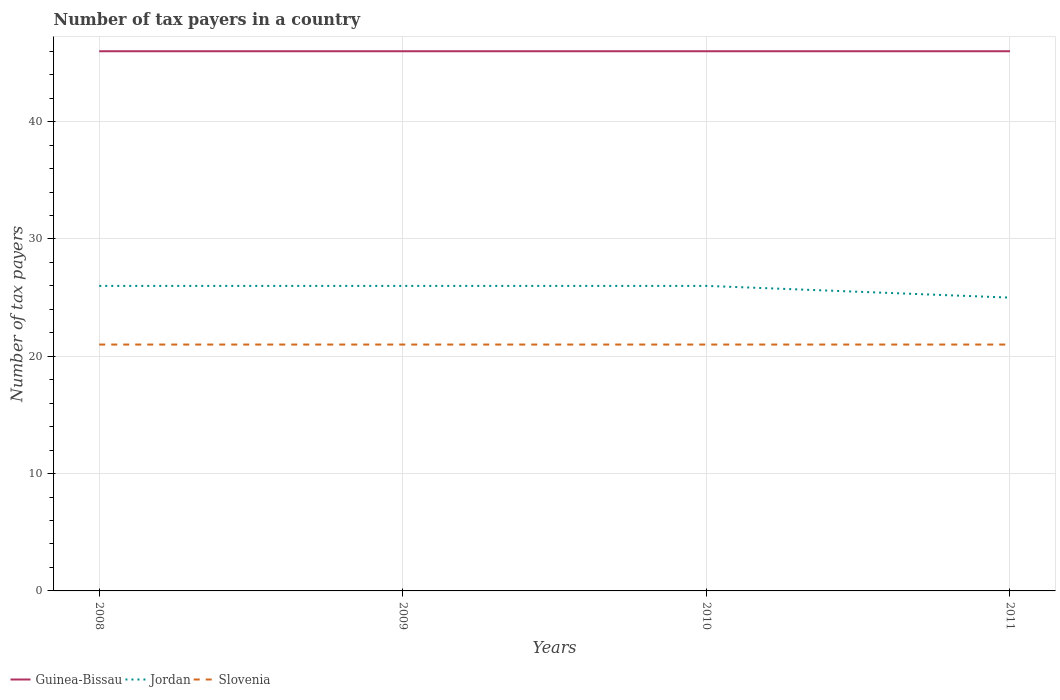How many different coloured lines are there?
Your answer should be compact. 3. Across all years, what is the maximum number of tax payers in in Slovenia?
Ensure brevity in your answer.  21. In which year was the number of tax payers in in Slovenia maximum?
Give a very brief answer. 2008. What is the difference between the highest and the second highest number of tax payers in in Jordan?
Offer a very short reply. 1. What is the difference between the highest and the lowest number of tax payers in in Slovenia?
Provide a succinct answer. 0. How many years are there in the graph?
Provide a short and direct response. 4. What is the difference between two consecutive major ticks on the Y-axis?
Your response must be concise. 10. Are the values on the major ticks of Y-axis written in scientific E-notation?
Ensure brevity in your answer.  No. Does the graph contain any zero values?
Provide a succinct answer. No. How are the legend labels stacked?
Your answer should be compact. Horizontal. What is the title of the graph?
Your answer should be compact. Number of tax payers in a country. Does "South Sudan" appear as one of the legend labels in the graph?
Your answer should be very brief. No. What is the label or title of the Y-axis?
Keep it short and to the point. Number of tax payers. What is the Number of tax payers in Jordan in 2008?
Offer a terse response. 26. What is the Number of tax payers in Slovenia in 2008?
Your answer should be very brief. 21. What is the Number of tax payers of Guinea-Bissau in 2009?
Offer a very short reply. 46. What is the Number of tax payers in Slovenia in 2009?
Your response must be concise. 21. What is the Number of tax payers in Guinea-Bissau in 2010?
Your answer should be compact. 46. What is the Number of tax payers of Slovenia in 2010?
Provide a succinct answer. 21. What is the Number of tax payers in Slovenia in 2011?
Your answer should be compact. 21. Across all years, what is the maximum Number of tax payers in Jordan?
Offer a very short reply. 26. Across all years, what is the maximum Number of tax payers of Slovenia?
Make the answer very short. 21. What is the total Number of tax payers of Guinea-Bissau in the graph?
Your answer should be very brief. 184. What is the total Number of tax payers in Jordan in the graph?
Provide a succinct answer. 103. What is the difference between the Number of tax payers in Guinea-Bissau in 2008 and that in 2009?
Make the answer very short. 0. What is the difference between the Number of tax payers in Jordan in 2008 and that in 2009?
Make the answer very short. 0. What is the difference between the Number of tax payers in Slovenia in 2008 and that in 2009?
Your answer should be very brief. 0. What is the difference between the Number of tax payers in Guinea-Bissau in 2008 and that in 2010?
Provide a short and direct response. 0. What is the difference between the Number of tax payers of Slovenia in 2008 and that in 2010?
Provide a succinct answer. 0. What is the difference between the Number of tax payers in Slovenia in 2008 and that in 2011?
Keep it short and to the point. 0. What is the difference between the Number of tax payers of Jordan in 2009 and that in 2011?
Your answer should be compact. 1. What is the difference between the Number of tax payers in Guinea-Bissau in 2010 and that in 2011?
Keep it short and to the point. 0. What is the difference between the Number of tax payers of Guinea-Bissau in 2008 and the Number of tax payers of Jordan in 2009?
Offer a very short reply. 20. What is the difference between the Number of tax payers in Guinea-Bissau in 2008 and the Number of tax payers in Slovenia in 2009?
Provide a succinct answer. 25. What is the difference between the Number of tax payers of Jordan in 2008 and the Number of tax payers of Slovenia in 2009?
Your answer should be very brief. 5. What is the difference between the Number of tax payers in Guinea-Bissau in 2008 and the Number of tax payers in Jordan in 2011?
Provide a succinct answer. 21. What is the difference between the Number of tax payers in Guinea-Bissau in 2008 and the Number of tax payers in Slovenia in 2011?
Give a very brief answer. 25. What is the difference between the Number of tax payers in Jordan in 2009 and the Number of tax payers in Slovenia in 2010?
Your answer should be compact. 5. What is the difference between the Number of tax payers of Jordan in 2009 and the Number of tax payers of Slovenia in 2011?
Your response must be concise. 5. What is the difference between the Number of tax payers in Jordan in 2010 and the Number of tax payers in Slovenia in 2011?
Your response must be concise. 5. What is the average Number of tax payers in Jordan per year?
Your response must be concise. 25.75. What is the average Number of tax payers in Slovenia per year?
Your answer should be compact. 21. In the year 2008, what is the difference between the Number of tax payers of Guinea-Bissau and Number of tax payers of Slovenia?
Your answer should be very brief. 25. In the year 2008, what is the difference between the Number of tax payers in Jordan and Number of tax payers in Slovenia?
Your response must be concise. 5. In the year 2009, what is the difference between the Number of tax payers in Guinea-Bissau and Number of tax payers in Jordan?
Provide a short and direct response. 20. In the year 2009, what is the difference between the Number of tax payers of Jordan and Number of tax payers of Slovenia?
Your answer should be very brief. 5. In the year 2011, what is the difference between the Number of tax payers in Jordan and Number of tax payers in Slovenia?
Provide a short and direct response. 4. What is the ratio of the Number of tax payers in Slovenia in 2008 to that in 2009?
Your response must be concise. 1. What is the ratio of the Number of tax payers of Jordan in 2008 to that in 2010?
Offer a very short reply. 1. What is the ratio of the Number of tax payers in Guinea-Bissau in 2008 to that in 2011?
Your response must be concise. 1. What is the ratio of the Number of tax payers in Jordan in 2008 to that in 2011?
Your answer should be very brief. 1.04. What is the ratio of the Number of tax payers of Guinea-Bissau in 2009 to that in 2010?
Offer a very short reply. 1. What is the ratio of the Number of tax payers of Slovenia in 2009 to that in 2010?
Provide a short and direct response. 1. What is the ratio of the Number of tax payers of Guinea-Bissau in 2009 to that in 2011?
Your answer should be very brief. 1. What is the ratio of the Number of tax payers in Guinea-Bissau in 2010 to that in 2011?
Offer a very short reply. 1. What is the difference between the highest and the second highest Number of tax payers of Jordan?
Provide a short and direct response. 0. What is the difference between the highest and the second highest Number of tax payers in Slovenia?
Keep it short and to the point. 0. What is the difference between the highest and the lowest Number of tax payers of Slovenia?
Your answer should be very brief. 0. 